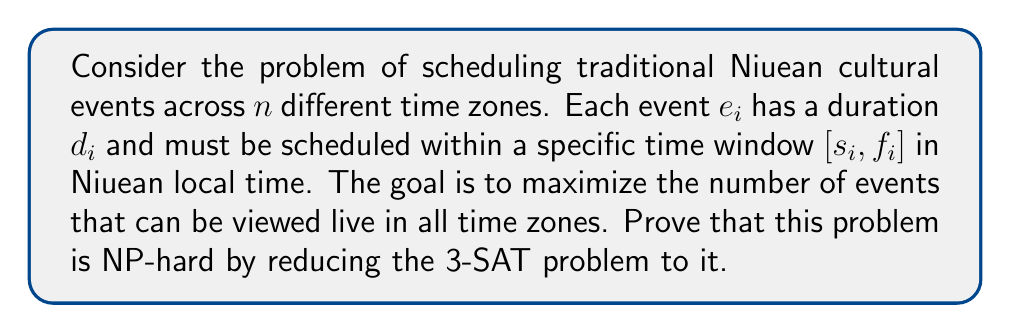Give your solution to this math problem. To prove that the Niuean cultural event scheduling problem is NP-hard, we will reduce the 3-SAT problem to it. Here's a step-by-step explanation:

1. 3-SAT Problem:
   Given a boolean formula in conjunctive normal form with 3 literals per clause, determine if there exists a satisfying assignment.

2. Reduction:
   For each 3-SAT instance with $m$ clauses and $n$ variables, we construct an instance of the Niuean event scheduling problem as follows:

   a) Create $2n$ time zones: $TZ_1, TZ_2, ..., TZ_{2n}$
   b) For each variable $x_i$, create two events: $e_i$ and $e'_i$
   c) Set the duration of all events to 1 hour: $d_i = d'_i = 1$
   d) Set the time windows for $e_i$ and $e'_i$ as:
      $s_i = 2i-2$, $f_i = 2i-1$
      $s'_i = 2i-1$, $f'_i = 2i$
   e) For each clause $C_j = (l_1 \lor l_2 \lor l_3)$, create an event $c_j$ with:
      $s_j = 2n$, $f_j = 2n+1$

3. Constraints:
   a) Event $e_i$ can be viewed in all time zones except $TZ_{2i-1}$
   b) Event $e'_i$ can be viewed in all time zones except $TZ_{2i}$
   c) Event $c_j$ can be viewed in all time zones except those corresponding to the negation of its literals

4. Equivalence:
   The 3-SAT instance is satisfiable if and only if we can schedule $n+m$ events in the Niuean problem.

5. Proof:
   - If 3-SAT is satisfiable:
     Schedule $e_i$ if $x_i$ is true, $e'_i$ if $x_i$ is false, and all clause events $c_j$
   - If Niuean problem has a solution with $n+m$ events:
     Assign $x_i$ true if $e_i$ is scheduled, false if $e'_i$ is scheduled

6. Complexity:
   The reduction can be done in polynomial time, and the Niuean problem is in NP (we can verify a solution in polynomial time).

Therefore, the Niuean cultural event scheduling problem is NP-hard.
Answer: The Niuean cultural event scheduling problem across multiple time zones is NP-hard. 